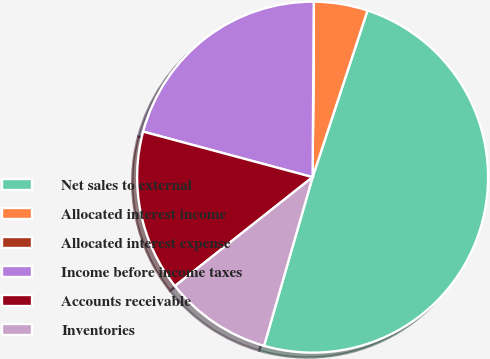Convert chart. <chart><loc_0><loc_0><loc_500><loc_500><pie_chart><fcel>Net sales to external<fcel>Allocated interest income<fcel>Allocated interest expense<fcel>Income before income taxes<fcel>Accounts receivable<fcel>Inventories<nl><fcel>49.4%<fcel>4.95%<fcel>0.01%<fcel>20.93%<fcel>14.83%<fcel>9.89%<nl></chart> 